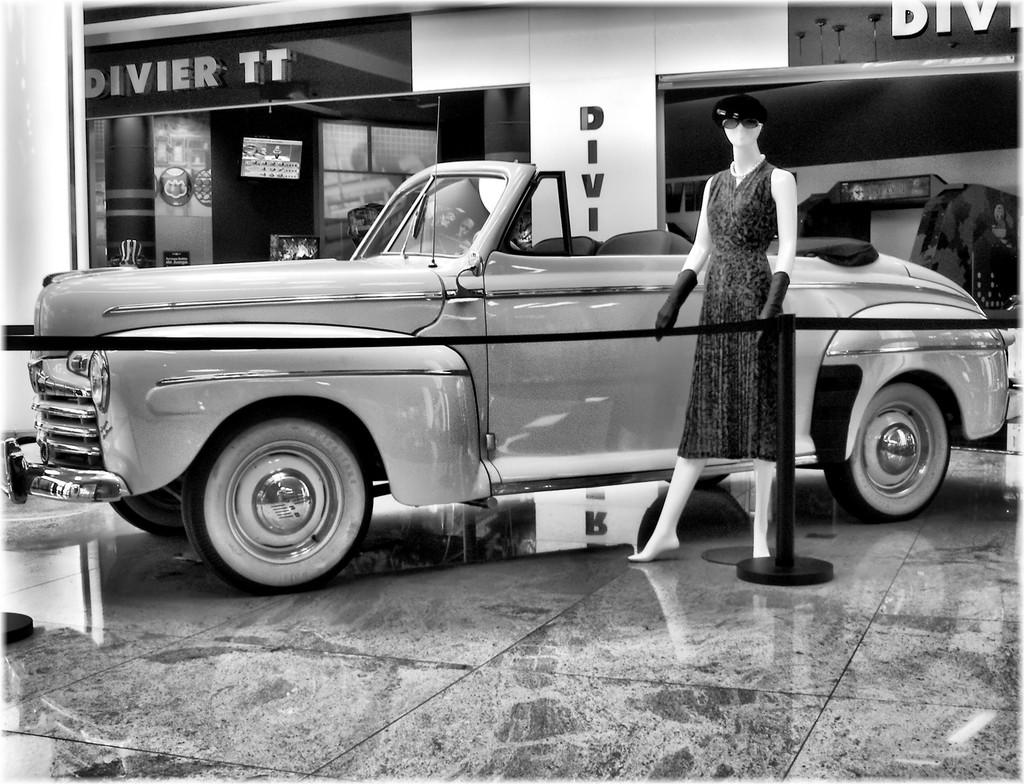What is the color scheme of the image? The image is black and white. What can be seen in the foreground of the image? There is a car and a mannequin in the image. What is the mannequin standing on? The mannequin is on marble ground. What is visible in the background of the image? There is a store in the background of the image. What type of mine is depicted in the image? There is no mine present in the image; it features a car, a mannequin, and a store. How long is the string used by the mannequin in the image? There is no string present in the image; the mannequin is not holding or interacting with any object. 